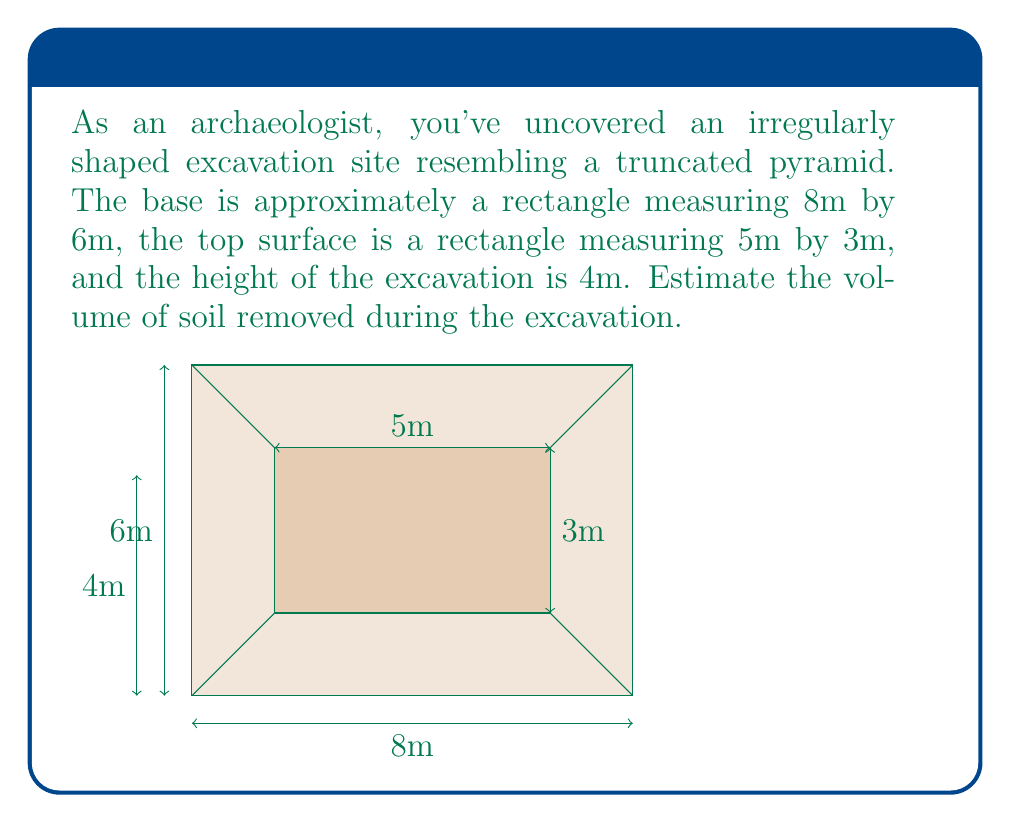Solve this math problem. To estimate the volume of this irregularly shaped excavation site, we can use the formula for the volume of a truncated pyramid:

$$ V = \frac{1}{3}h(A_1 + A_2 + \sqrt{A_1A_2}) $$

Where:
- $V$ is the volume
- $h$ is the height
- $A_1$ is the area of the base
- $A_2$ is the area of the top surface

Let's solve this step by step:

1) Calculate the area of the base ($A_1$):
   $A_1 = 8m \times 6m = 48m^2$

2) Calculate the area of the top surface ($A_2$):
   $A_2 = 5m \times 3m = 15m^2$

3) Calculate $\sqrt{A_1A_2}$:
   $\sqrt{A_1A_2} = \sqrt{48m^2 \times 15m^2} = \sqrt{720m^4} \approx 26.83m^2$

4) Apply the formula:
   $V = \frac{1}{3} \times 4m \times (48m^2 + 15m^2 + 26.83m^2)$
   $V = \frac{4}{3} \times 89.83m^2$
   $V \approx 119.77m^3$

Therefore, the estimated volume of soil removed during the excavation is approximately 119.77 cubic meters.
Answer: $119.77m^3$ 